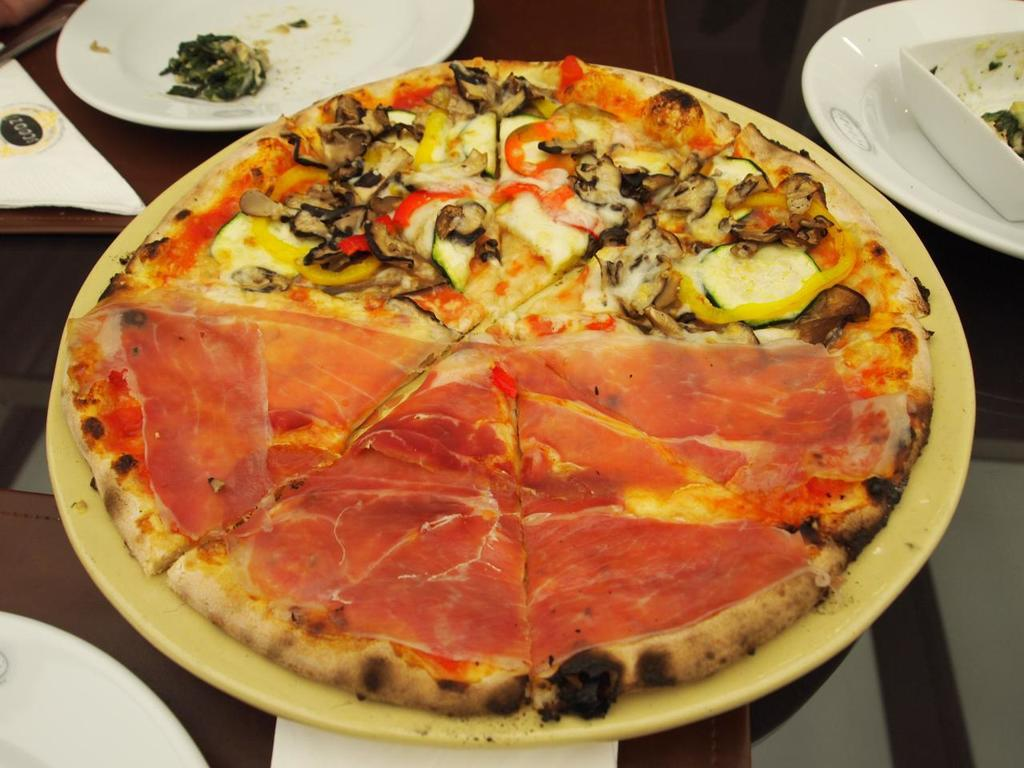What piece of furniture is visible in the image? There is a table in the image. What items are placed on the table? There are plates and tissue papers on the table. What type of food can be seen on one of the plates? There is a pizza on one of the plates. What type of drug is the stranger offering to the person in the image? There is no stranger or drug present in the image; it only features a table with plates, tissue papers, and a pizza. 